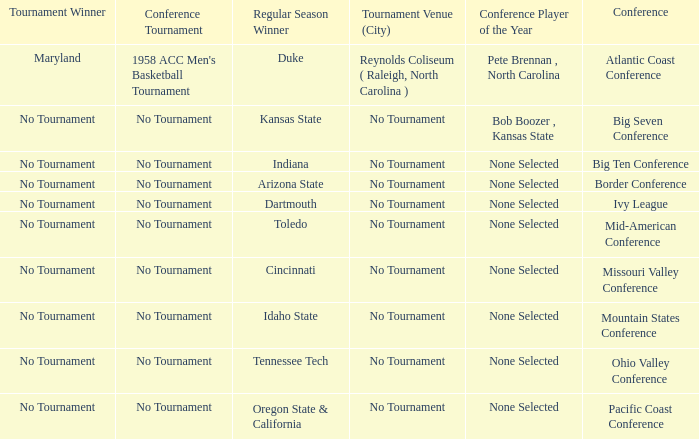What was the conference when Arizona State won the regular season? Border Conference. 